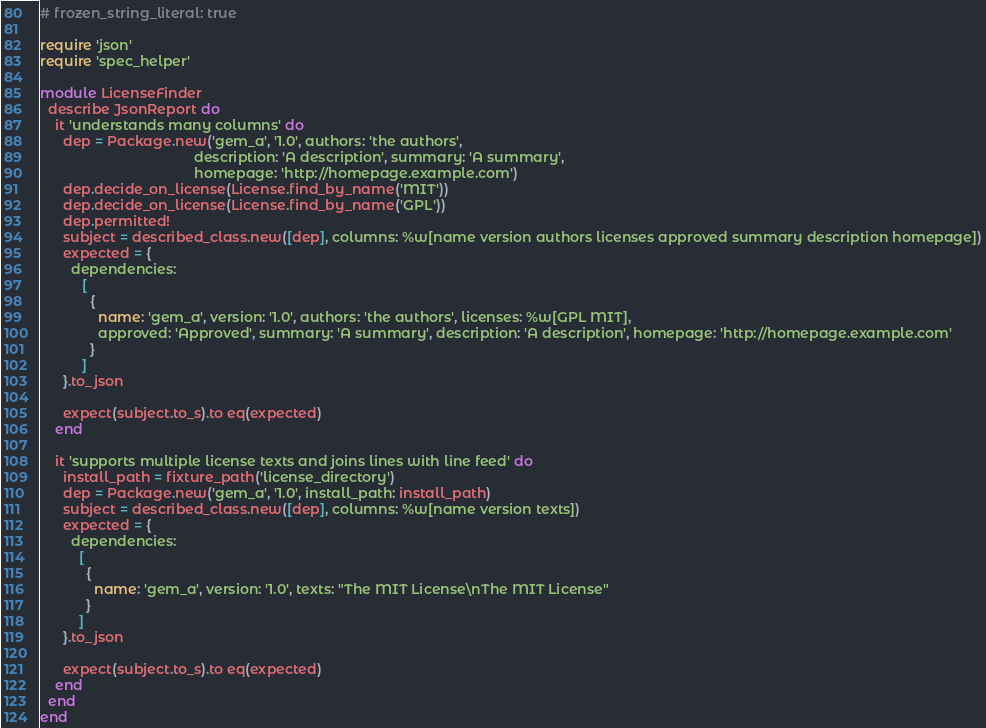Convert code to text. <code><loc_0><loc_0><loc_500><loc_500><_Ruby_># frozen_string_literal: true

require 'json'
require 'spec_helper'

module LicenseFinder
  describe JsonReport do
    it 'understands many columns' do
      dep = Package.new('gem_a', '1.0', authors: 'the authors',
                                        description: 'A description', summary: 'A summary',
                                        homepage: 'http://homepage.example.com')
      dep.decide_on_license(License.find_by_name('MIT'))
      dep.decide_on_license(License.find_by_name('GPL'))
      dep.permitted!
      subject = described_class.new([dep], columns: %w[name version authors licenses approved summary description homepage])
      expected = {
        dependencies:
           [
             {
               name: 'gem_a', version: '1.0', authors: 'the authors', licenses: %w[GPL MIT],
               approved: 'Approved', summary: 'A summary', description: 'A description', homepage: 'http://homepage.example.com'
             }
           ]
      }.to_json

      expect(subject.to_s).to eq(expected)
    end

    it 'supports multiple license texts and joins lines with line feed' do
      install_path = fixture_path('license_directory')
      dep = Package.new('gem_a', '1.0', install_path: install_path)
      subject = described_class.new([dep], columns: %w[name version texts])
      expected = {
        dependencies:
          [
            {
              name: 'gem_a', version: '1.0', texts: "The MIT License\nThe MIT License"
            }
          ]
      }.to_json

      expect(subject.to_s).to eq(expected)
    end
  end
end
</code> 